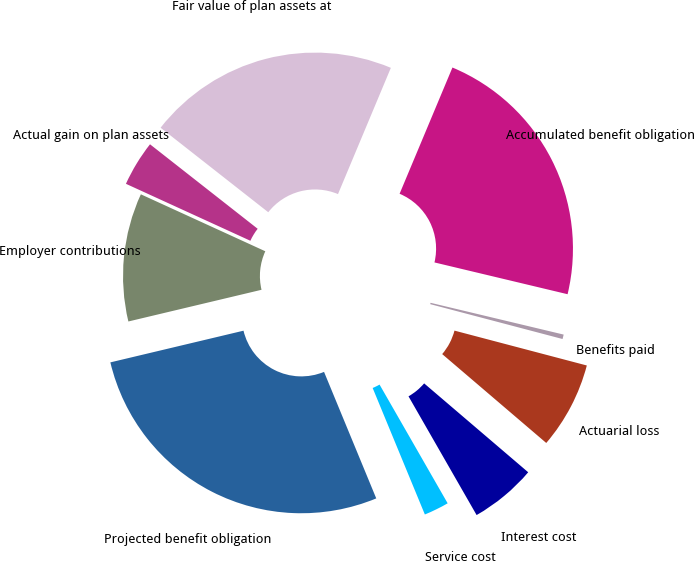Convert chart to OTSL. <chart><loc_0><loc_0><loc_500><loc_500><pie_chart><fcel>Projected benefit obligation<fcel>Service cost<fcel>Interest cost<fcel>Actuarial loss<fcel>Benefits paid<fcel>Accumulated benefit obligation<fcel>Fair value of plan assets at<fcel>Actual gain on plan assets<fcel>Employer contributions<nl><fcel>27.51%<fcel>2.06%<fcel>5.46%<fcel>7.15%<fcel>0.37%<fcel>22.42%<fcel>20.72%<fcel>3.76%<fcel>10.55%<nl></chart> 